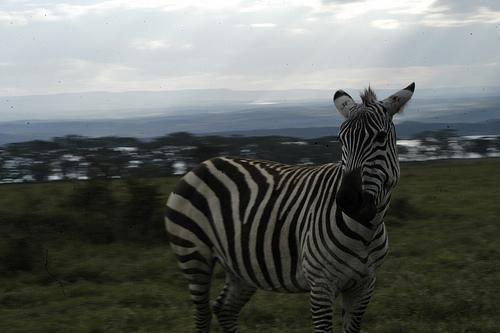How many zebras are there?
Give a very brief answer. 1. 